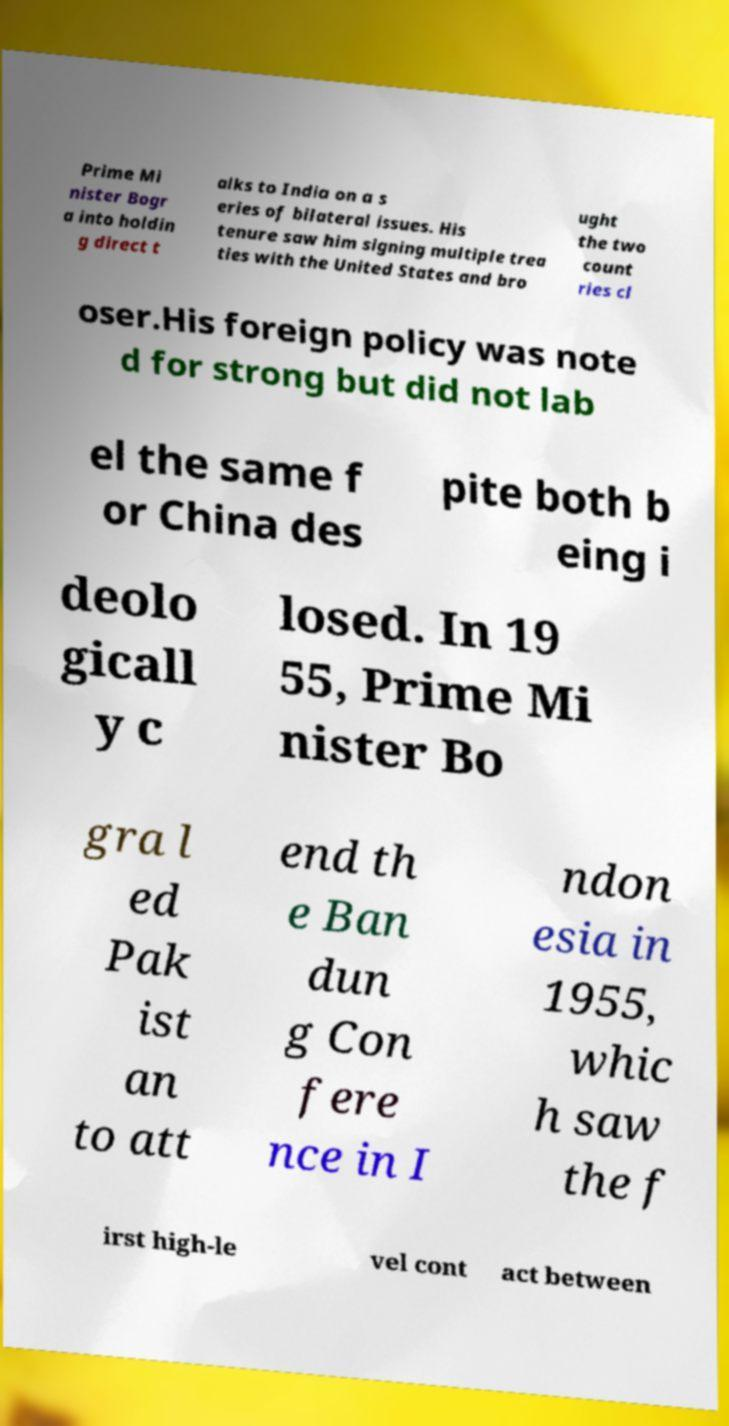Could you extract and type out the text from this image? Prime Mi nister Bogr a into holdin g direct t alks to India on a s eries of bilateral issues. His tenure saw him signing multiple trea ties with the United States and bro ught the two count ries cl oser.His foreign policy was note d for strong but did not lab el the same f or China des pite both b eing i deolo gicall y c losed. In 19 55, Prime Mi nister Bo gra l ed Pak ist an to att end th e Ban dun g Con fere nce in I ndon esia in 1955, whic h saw the f irst high-le vel cont act between 